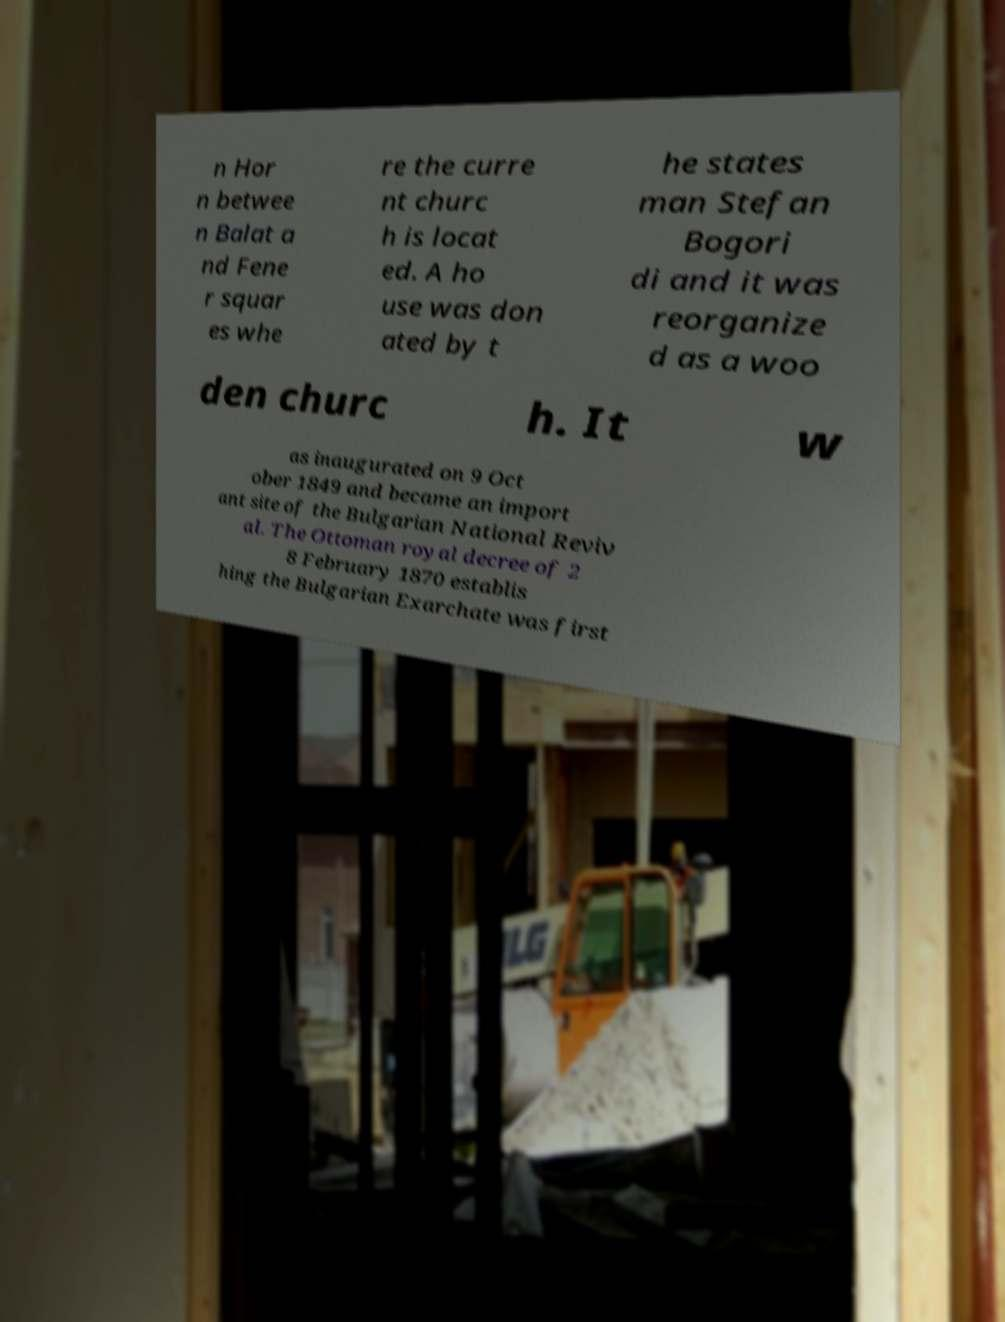There's text embedded in this image that I need extracted. Can you transcribe it verbatim? n Hor n betwee n Balat a nd Fene r squar es whe re the curre nt churc h is locat ed. A ho use was don ated by t he states man Stefan Bogori di and it was reorganize d as a woo den churc h. It w as inaugurated on 9 Oct ober 1849 and became an import ant site of the Bulgarian National Reviv al. The Ottoman royal decree of 2 8 February 1870 establis hing the Bulgarian Exarchate was first 